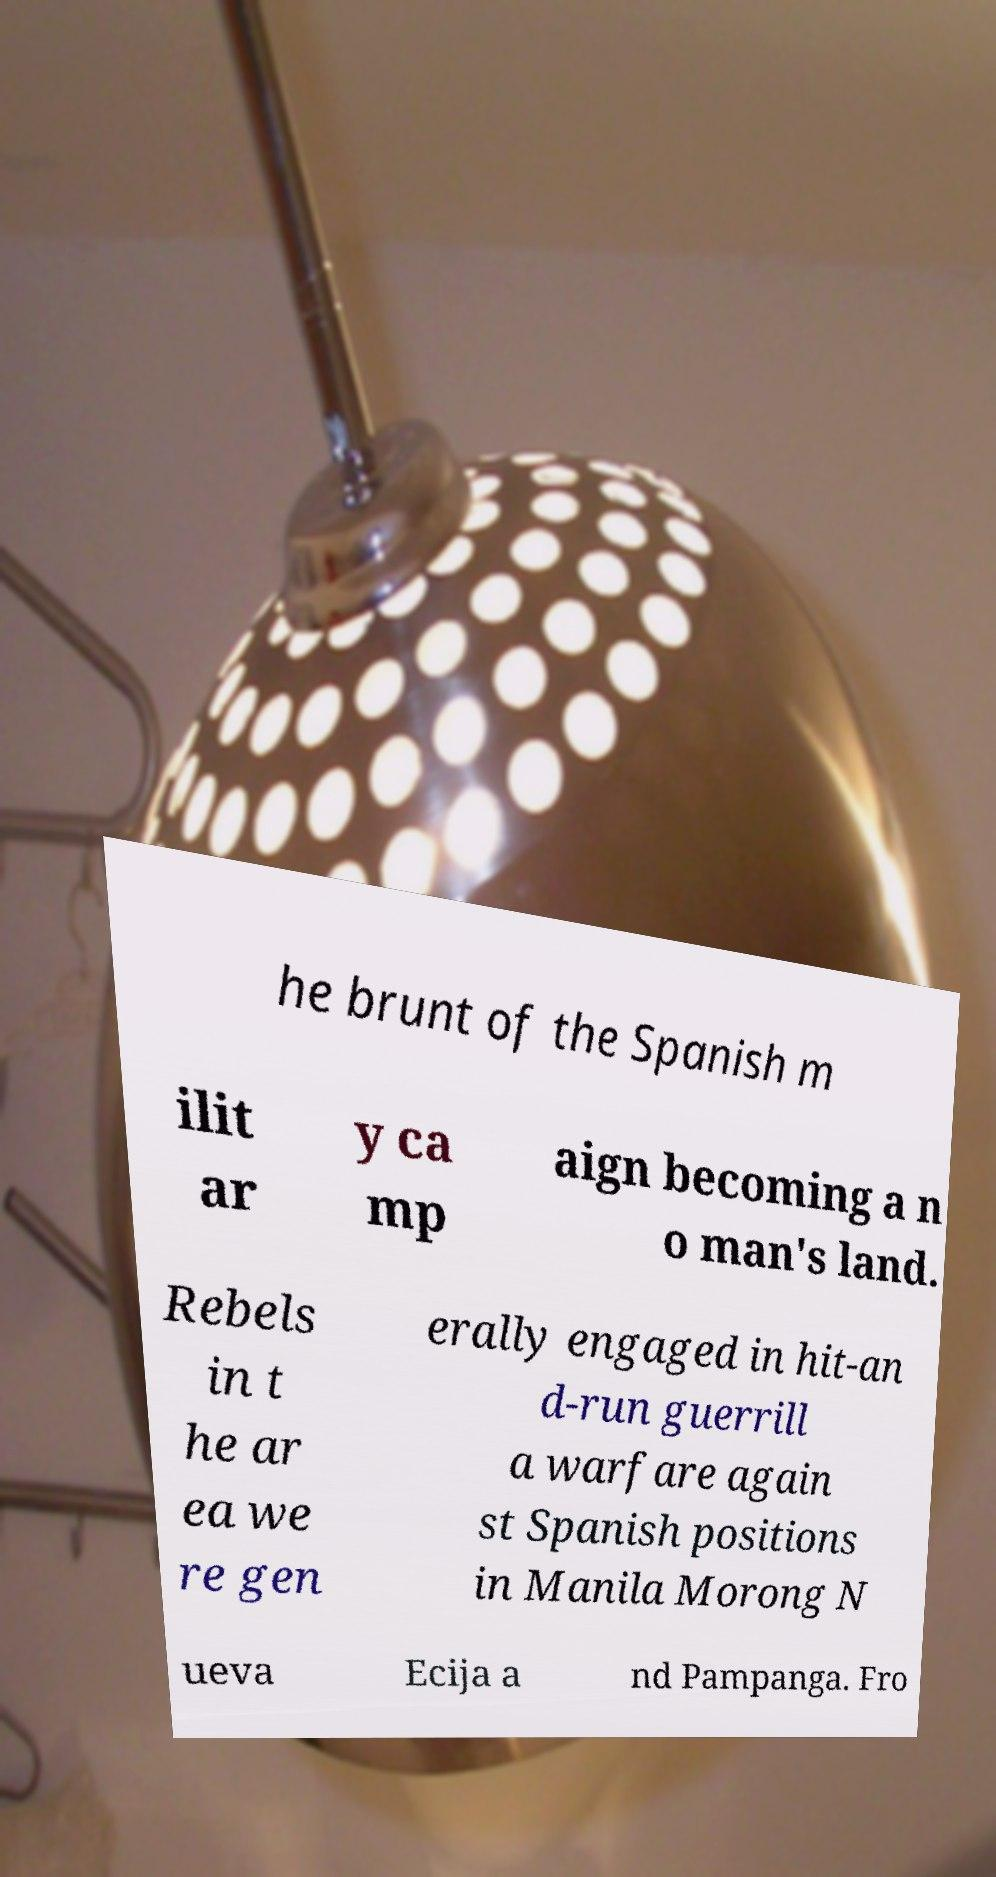What messages or text are displayed in this image? I need them in a readable, typed format. he brunt of the Spanish m ilit ar y ca mp aign becoming a n o man's land. Rebels in t he ar ea we re gen erally engaged in hit-an d-run guerrill a warfare again st Spanish positions in Manila Morong N ueva Ecija a nd Pampanga. Fro 